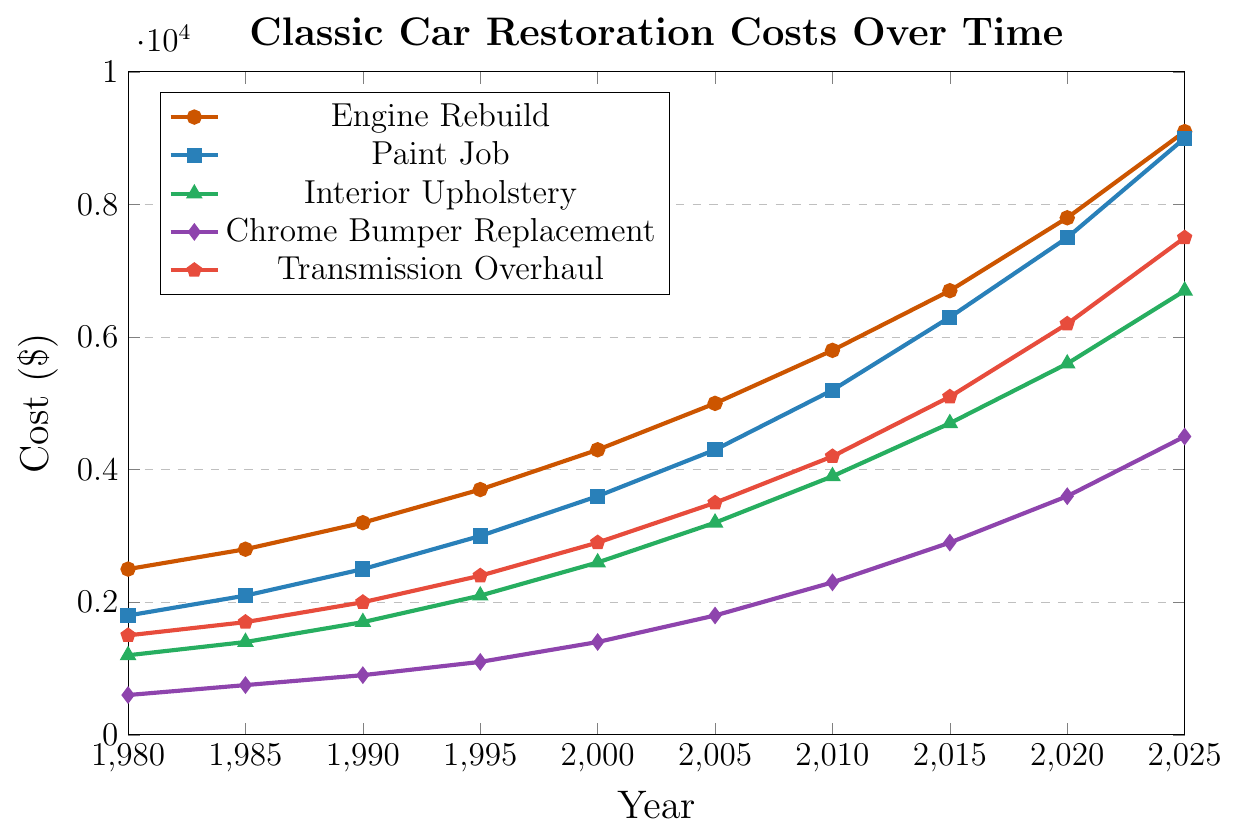What's the trend in restoration costs for an engine rebuild from 1980 to 2025? The cost for an engine rebuild increases over time. In 1980, it starts at $2500 and steadily rises each period, reaching $9100 in 2025.
Answer: Increasing trend Which restoration component has the most significant cost difference between 1980 and 2025? To find this, calculate the cost difference for each component:
- Engine Rebuild: $9100 - $2500 = $6600
- Paint Job: $9000 - $1800 = $7200
- Interior Upholstery: $6700 - $1200 = $5500
- Chrome Bumper Replacement: $4500 - $600 = $3900
- Transmission Overhaul: $7500 - $1500 = $6000
The paint job shows the highest cost difference ($7200).
Answer: Paint Job In which year did the cost for a paint job surpass the cost for an engine rebuild for the first time? Check the costs for each year:
- 1980: Paint Job ($1800), Engine Rebuild ($2500)
- 1985: Paint Job ($2100), Engine Rebuild ($2800)
- 1990: Paint Job ($2500), Engine Rebuild ($3200)
- 1995: Paint Job ($3000), Engine Rebuild ($3700)
- 2000: Paint Job ($3600), Engine Rebuild ($4300)
- 2005: Paint Job ($4300), Engine Rebuild ($5000)
- 2010: Paint Job ($5200), Engine Rebuild ($5800)
- 2015: Paint Job ($6300), Engine Rebuild ($6700)
- 2020: Paint Job ($7500), Engine Rebuild ($7800)
- 2025: Paint Job ($9000), Engine Rebuild ($9100)
The costs for a paint job never surpassed the cost for an engine rebuild.
Answer: Never When comparing the costs between 1990 and 2000, which component had the highest percentage increase? Calculate the percentage increase for each component:
- Engine Rebuild: ($4300 - $3200) / $3200 ≈ 34.38%
- Paint Job: ($3600 - $2500) / $2500 = 44%
- Interior Upholstery: ($2600 - $1700) / $1700 ≈ 52.94%
- Chrome Bumper Replacement: ($1400 - $900) / $900 ≈ 55.56%
- Transmission Overhaul: ($2900 - $2000) / $2000 = 45%
The highest percentage increase is for Chrome Bumper Replacement (55.56%).
Answer: Chrome Bumper Replacement What is the average cost of an interior upholstery job across all the recorded years? Add up the costs and divide by the number of years:
(1200 + 1400 + 1700 + 2100 + 2600 + 3200 + 3900 + 4700 + 5600 + 6700) / 10 = 3310
Answer: $3310 What is the overall trend in chrome bumper replacement costs from 1980 to 2025? The cost of chrome bumper replacement shows an increasing trend. It starts at $600 in 1980 and steadily increases to $4500 by 2025.
Answer: Increasing trend In 2025, how does the cost of a transmission overhaul compare to the cost of an engine rebuild? Compare the costs:
- Transmission Overhaul: $7500
- Engine Rebuild: $9100
Thus, the cost of a transmission overhaul is less than the cost of an engine rebuild.
Answer: Less than Which component's cost saw the least increase from 1980 to 2025? Calculate the increase for each component:
- Engine Rebuild: $9100 - $2500 = $6600
- Paint Job: $9000 - $1800 = $7200
- Interior Upholstery: $6700 - $1200 = $5500
- Chrome Bumper Replacement: $4500 - $600 = $3900
- Transmission Overhaul: $7500 - $1500 = $6000
Chrome Bumper Replacement saw the least increase ($3900).
Answer: Chrome Bumper Replacement 